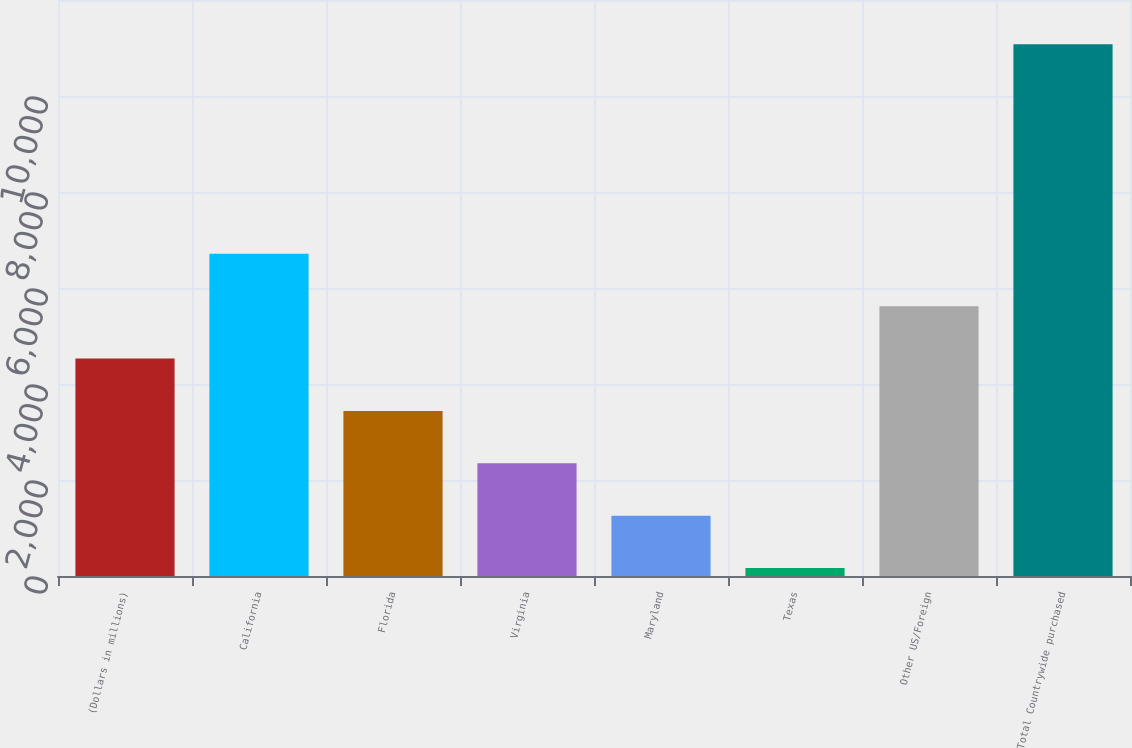<chart> <loc_0><loc_0><loc_500><loc_500><bar_chart><fcel>(Dollars in millions)<fcel>California<fcel>Florida<fcel>Virginia<fcel>Maryland<fcel>Texas<fcel>Other US/Foreign<fcel>Total Countrywide purchased<nl><fcel>4530.4<fcel>6712.6<fcel>3439.3<fcel>2348.2<fcel>1257.1<fcel>166<fcel>5621.5<fcel>11077<nl></chart> 